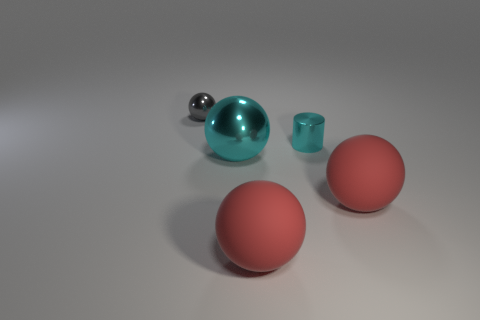Subtract all cyan spheres. How many spheres are left? 3 Add 3 cyan metal cylinders. How many objects exist? 8 Subtract all yellow cylinders. How many red balls are left? 2 Subtract all gray balls. How many balls are left? 3 Subtract all balls. How many objects are left? 1 Add 2 red rubber objects. How many red rubber objects are left? 4 Add 2 cyan shiny cylinders. How many cyan shiny cylinders exist? 3 Subtract 0 blue balls. How many objects are left? 5 Subtract 1 cylinders. How many cylinders are left? 0 Subtract all blue cylinders. Subtract all blue balls. How many cylinders are left? 1 